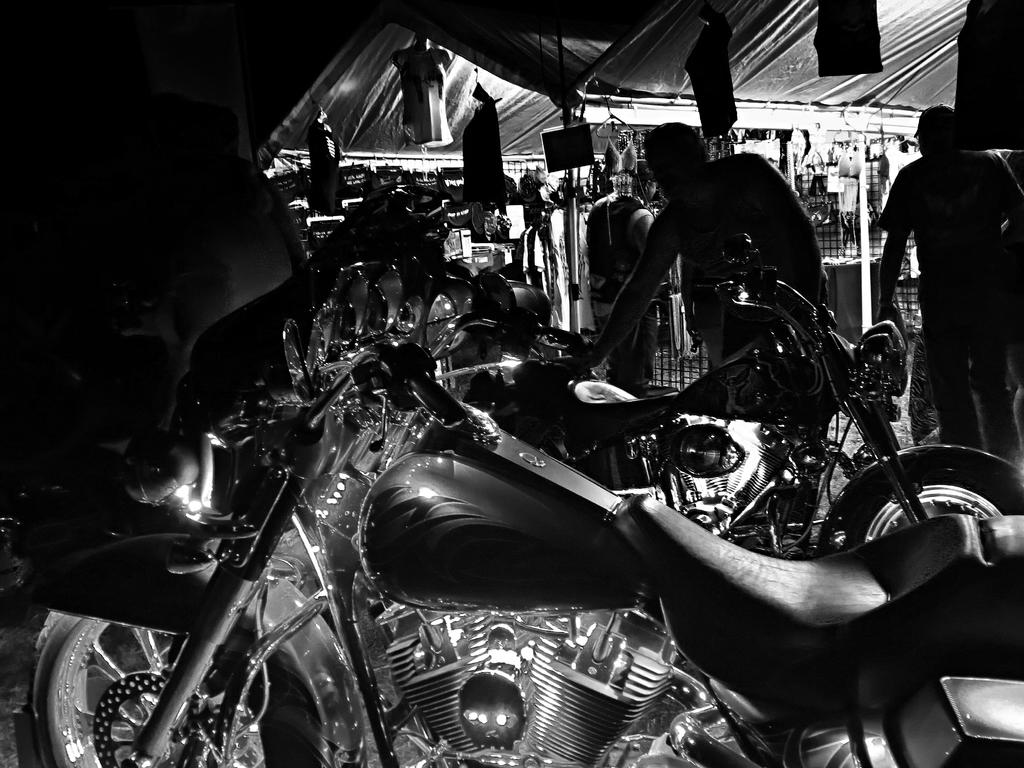What is the color scheme of the image? The image is black and white. What can be seen in the image besides the color scheme? There are bikes in the image. Where are the men located in the image? The men are on the right side of the image. What is located at the top of the image? There is a shelter at the top of the image. What is hanging from the shelter? Things are hanging from the shelter. How many trucks are parked next to the bikes in the image? There are no trucks present in the image; only bikes are visible. What type of drop can be seen falling from the shelter in the image? There is no drop falling from the shelter in the image; only things are hanging from it. 